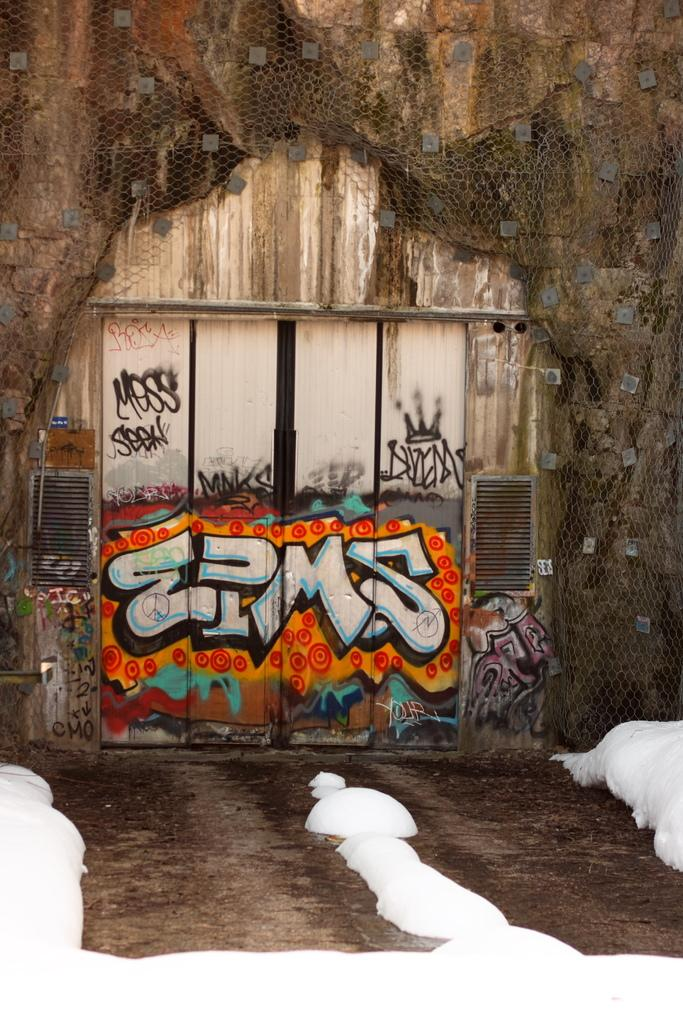What type of building is in the image? There is a wooden building in the image. What feature is present in the middle of the building? The building has a door in the middle. What is on the door of the building? There is graffiti on the door. What can be seen on the wall of the building? There is a net on the wall of the building. What type of cake is being served on the sofa in the image? There is no cake or sofa present in the image; it only features a wooden building with a door, graffiti, and a net on the wall. 